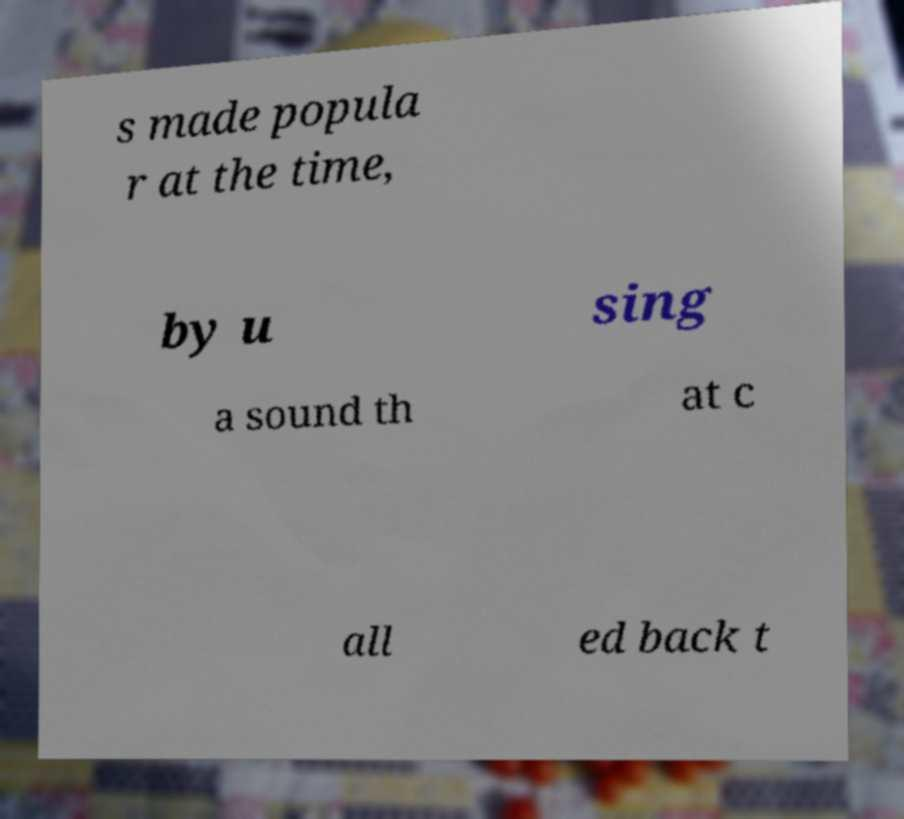Can you accurately transcribe the text from the provided image for me? s made popula r at the time, by u sing a sound th at c all ed back t 